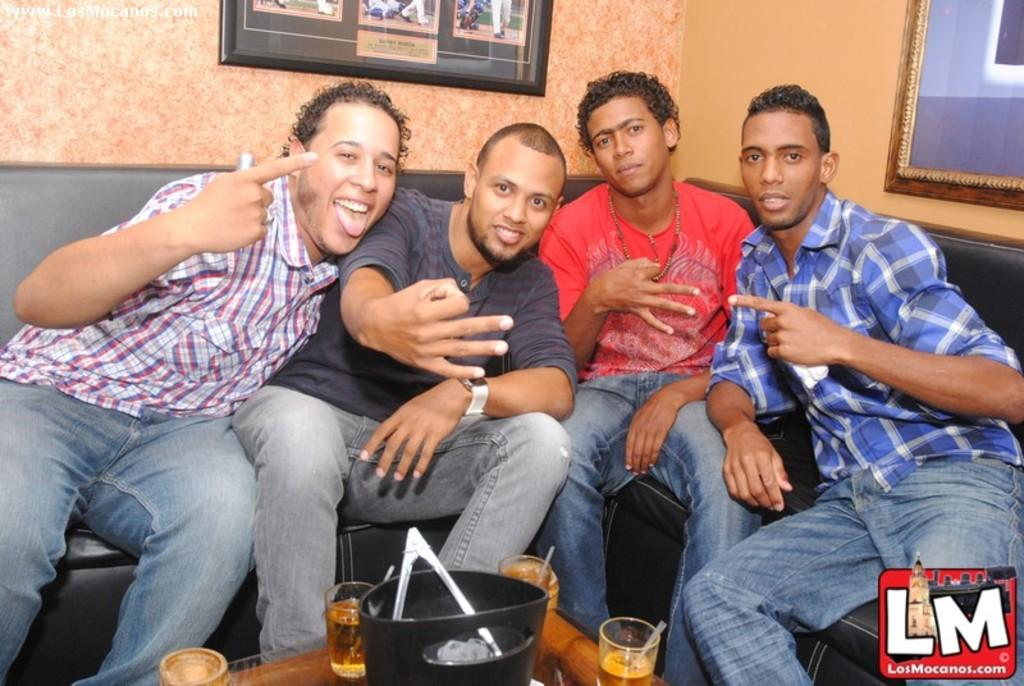What are the people in the image doing? There is a group of people sitting on a sofa in the image. What is in front of the sofa? There is a table in front of the sofa. What objects can be seen on the table? There are glasses on the table. What can be seen in the background of the image? There are photo frames and a wall visible in the background. What type of pie is being served in the image? There is no pie present in the image. What time of day is it in the image, based on the presence of a morning sign? There is no sign, including a morning sign, present in the image. 